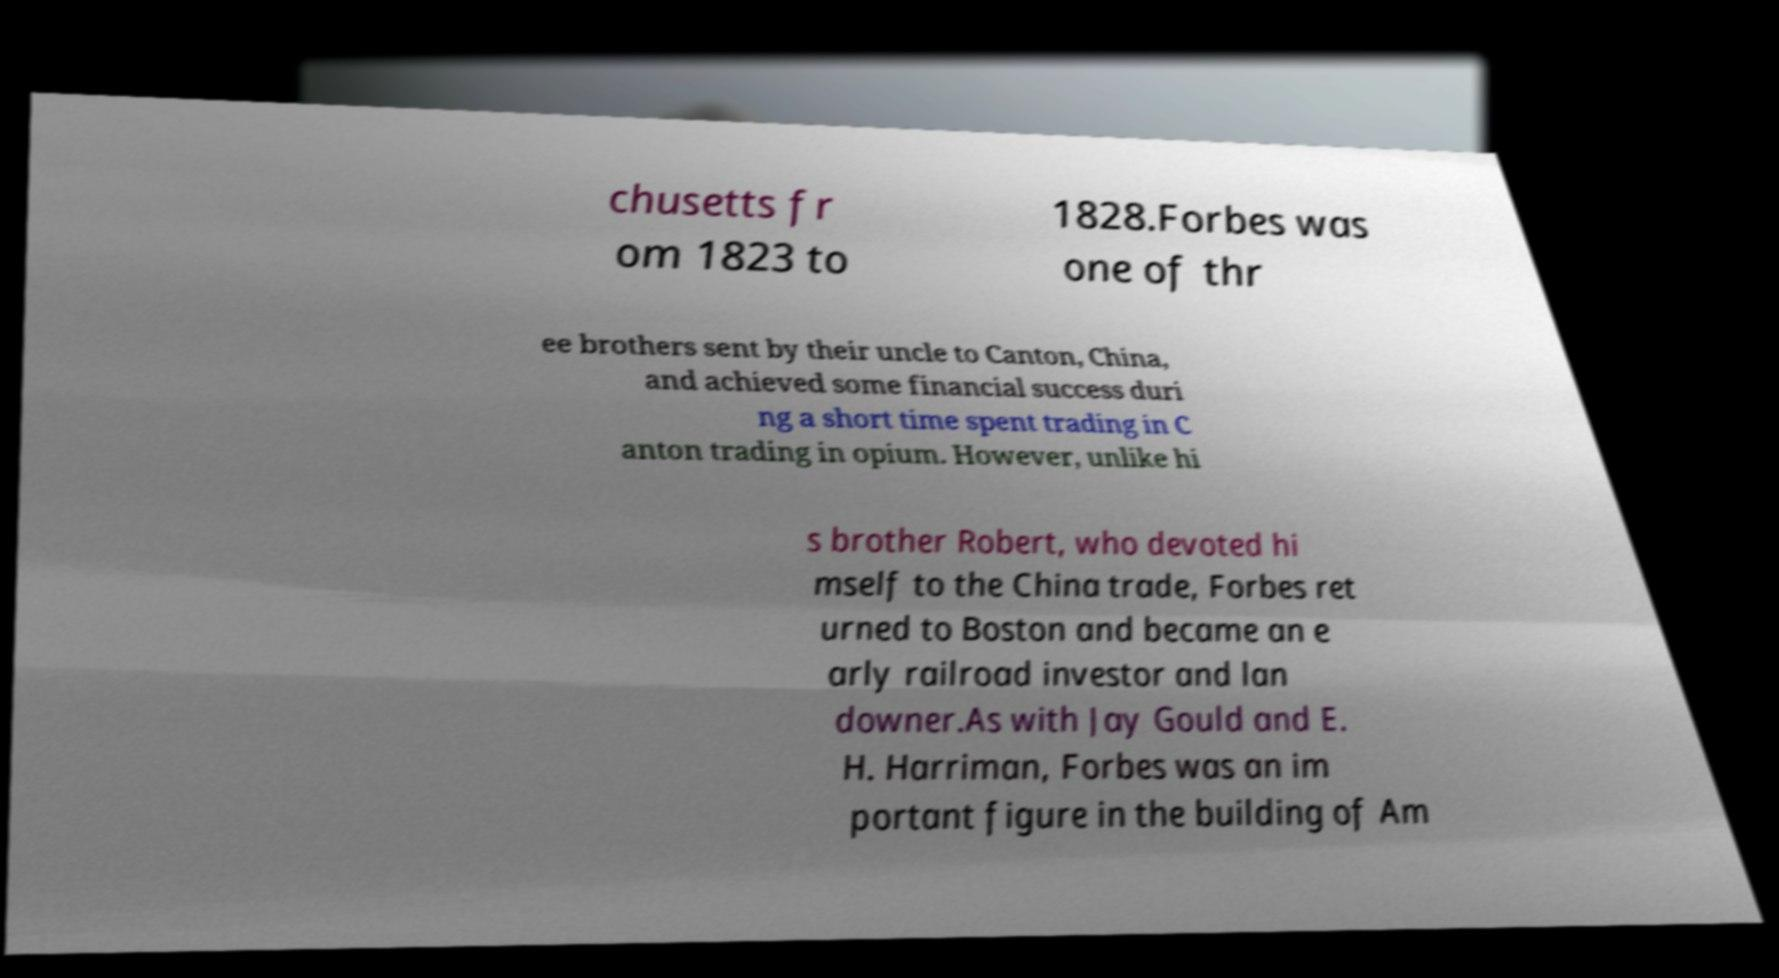Please identify and transcribe the text found in this image. chusetts fr om 1823 to 1828.Forbes was one of thr ee brothers sent by their uncle to Canton, China, and achieved some financial success duri ng a short time spent trading in C anton trading in opium. However, unlike hi s brother Robert, who devoted hi mself to the China trade, Forbes ret urned to Boston and became an e arly railroad investor and lan downer.As with Jay Gould and E. H. Harriman, Forbes was an im portant figure in the building of Am 